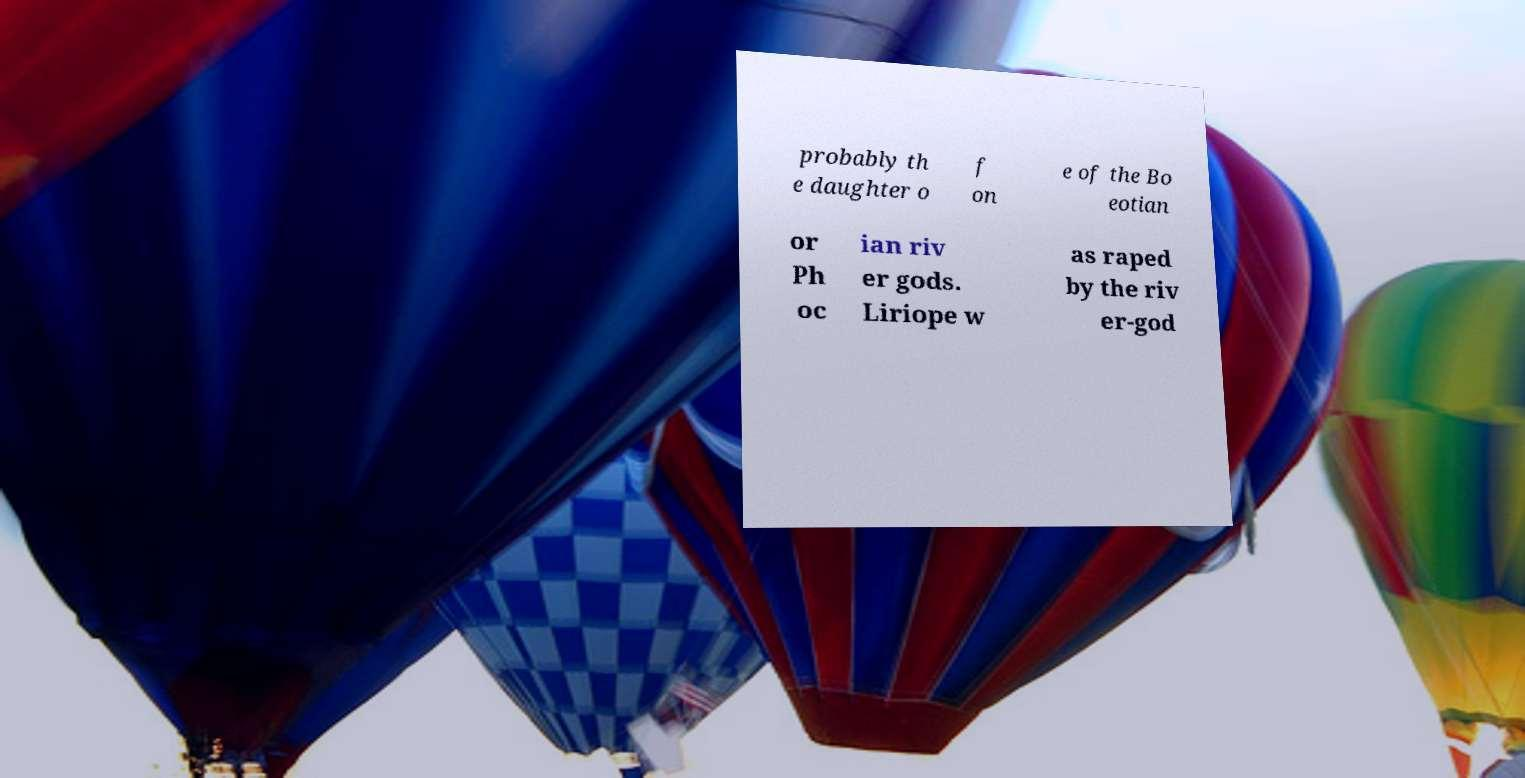Can you read and provide the text displayed in the image?This photo seems to have some interesting text. Can you extract and type it out for me? probably th e daughter o f on e of the Bo eotian or Ph oc ian riv er gods. Liriope w as raped by the riv er-god 